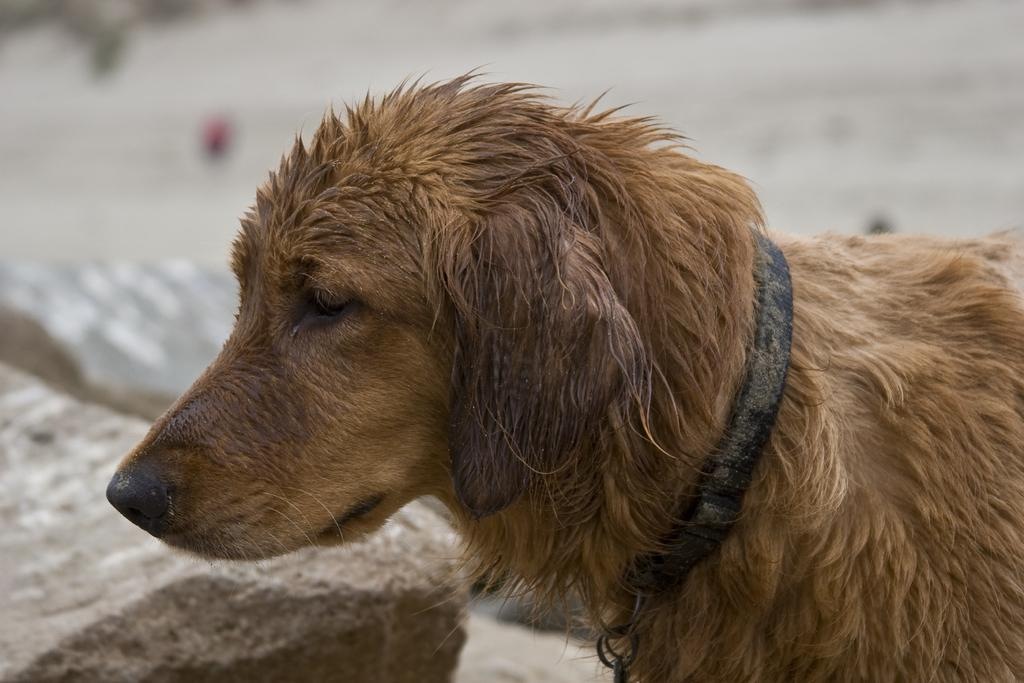What type of animal is in the image? There is a dog in the image. What colors can be seen on the dog? The dog is in cream and brown color. What can be seen in the background of the image? There are rocks visible in the background of the image. What type of disease is affecting the kitten in the image? There is no kitten present in the image, and therefore no disease can be observed. What type of plastic object can be seen in the image? There is no plastic object present in the image. 